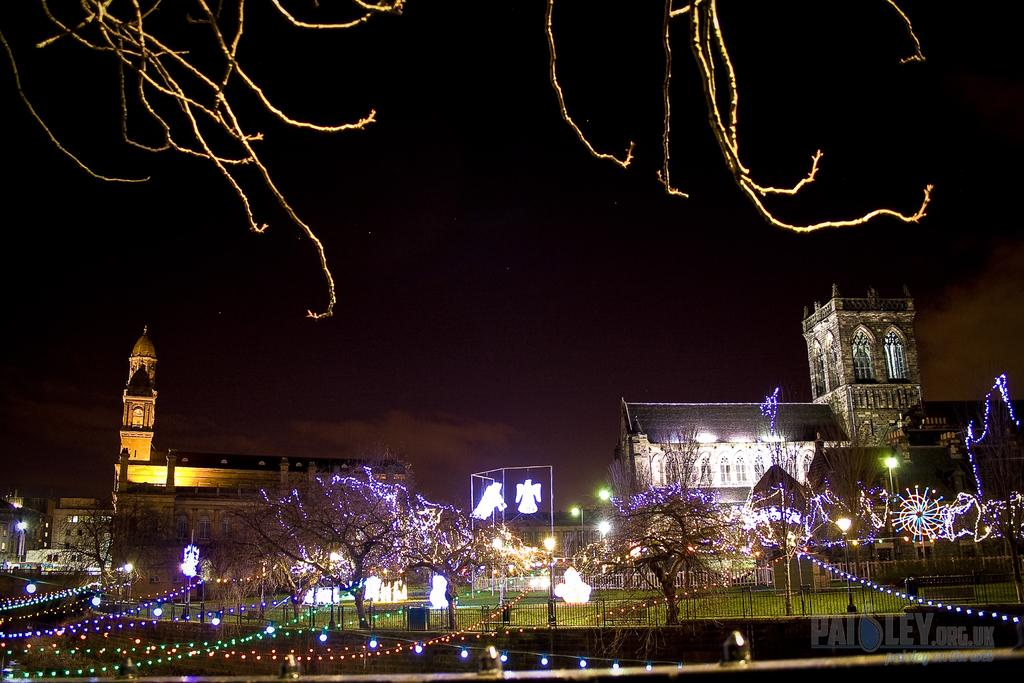What is located in the center of the image? There are buildings, lights, trees, and a railing in the center of the image. What type of surface can be seen at the bottom of the image? There is a wall and grass at the bottom of the image. What is visible at the top of the image? The sky is visible at the top of the image. What type of leather is visible on the wall at the bottom of the image? There is no leather visible on the wall at the bottom of the image. Can you read the letter that is written on the grass at the bottom of the image? There is no letter written on the grass at the bottom of the image. 